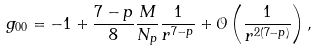<formula> <loc_0><loc_0><loc_500><loc_500>g _ { 0 0 } = - 1 + \frac { 7 - p } { 8 } \frac { M } { N _ { p } } \frac { 1 } { r ^ { 7 - p } } + \mathcal { O } \left ( \frac { 1 } { r ^ { 2 ( 7 - p ) } } \right ) ,</formula> 